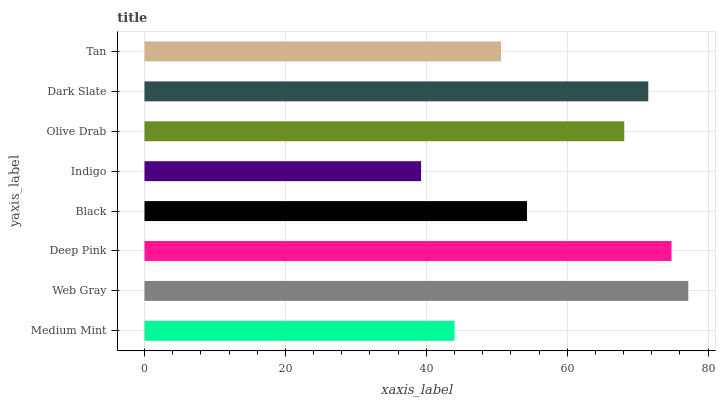Is Indigo the minimum?
Answer yes or no. Yes. Is Web Gray the maximum?
Answer yes or no. Yes. Is Deep Pink the minimum?
Answer yes or no. No. Is Deep Pink the maximum?
Answer yes or no. No. Is Web Gray greater than Deep Pink?
Answer yes or no. Yes. Is Deep Pink less than Web Gray?
Answer yes or no. Yes. Is Deep Pink greater than Web Gray?
Answer yes or no. No. Is Web Gray less than Deep Pink?
Answer yes or no. No. Is Olive Drab the high median?
Answer yes or no. Yes. Is Black the low median?
Answer yes or no. Yes. Is Black the high median?
Answer yes or no. No. Is Medium Mint the low median?
Answer yes or no. No. 